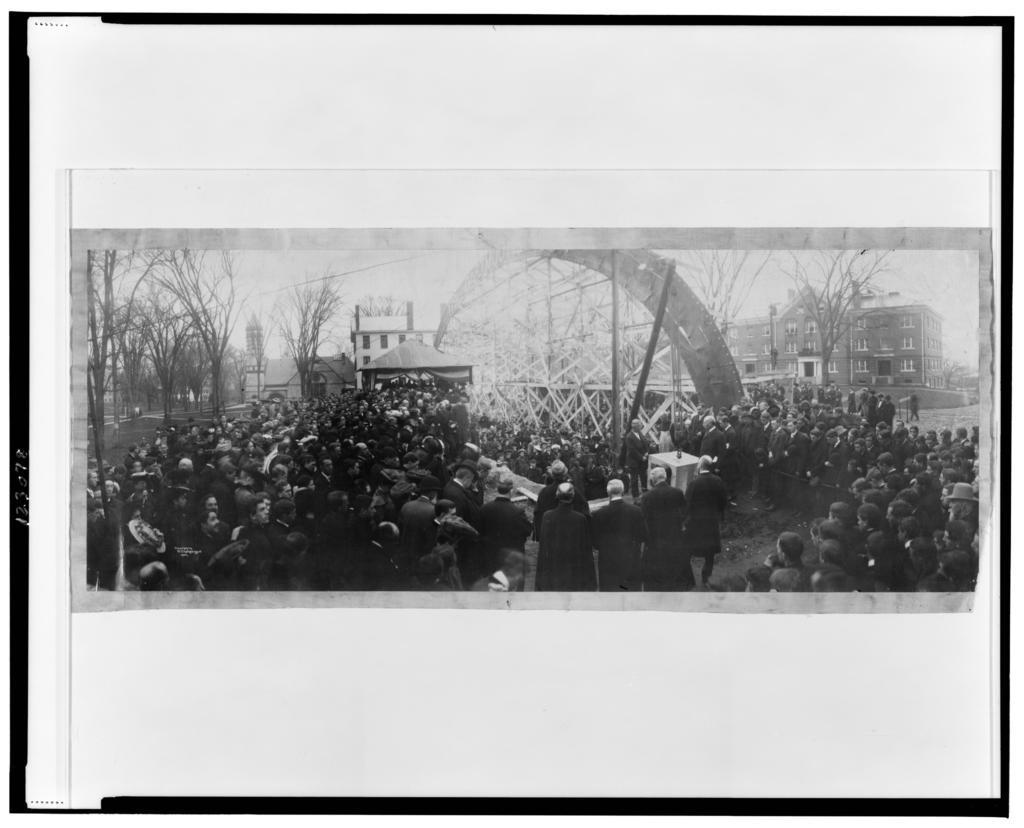Please provide a concise description of this image. This image is a black and white image. This image consists of a poster with an image. In this image many people are standing on the road and there are a few trees and buildings. 